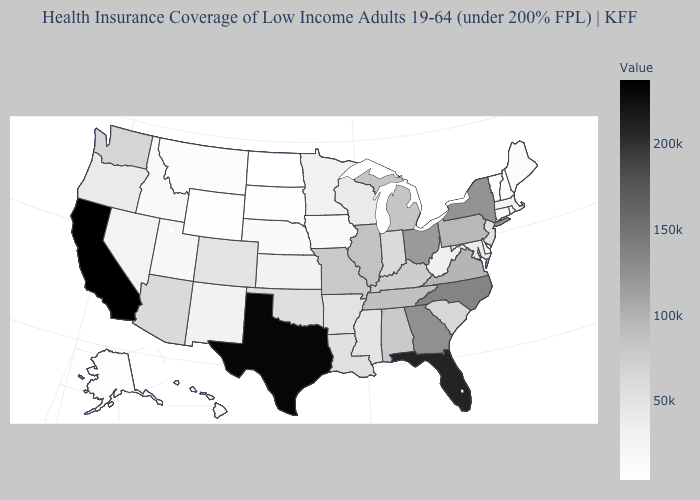Does the map have missing data?
Be succinct. No. Which states have the highest value in the USA?
Concise answer only. California. Which states hav the highest value in the West?
Write a very short answer. California. Among the states that border Oregon , does California have the lowest value?
Answer briefly. No. 